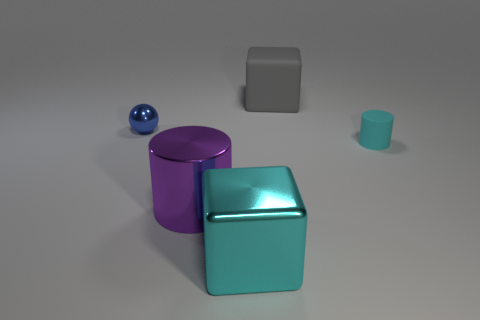Add 5 large gray rubber cylinders. How many objects exist? 10 Subtract all cubes. How many objects are left? 3 Add 4 purple shiny cylinders. How many purple shiny cylinders are left? 5 Add 4 big cubes. How many big cubes exist? 6 Subtract 0 purple spheres. How many objects are left? 5 Subtract all large blue metal things. Subtract all matte blocks. How many objects are left? 4 